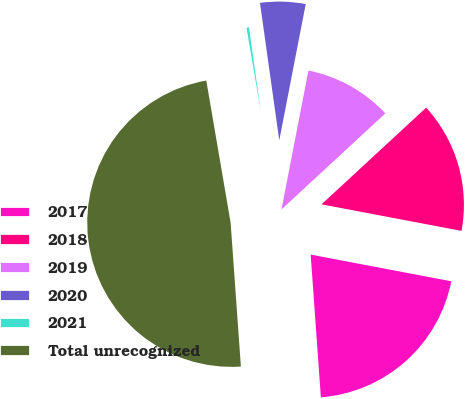Convert chart to OTSL. <chart><loc_0><loc_0><loc_500><loc_500><pie_chart><fcel>2017<fcel>2018<fcel>2019<fcel>2020<fcel>2021<fcel>Total unrecognized<nl><fcel>20.88%<fcel>14.86%<fcel>10.07%<fcel>5.27%<fcel>0.48%<fcel>48.43%<nl></chart> 